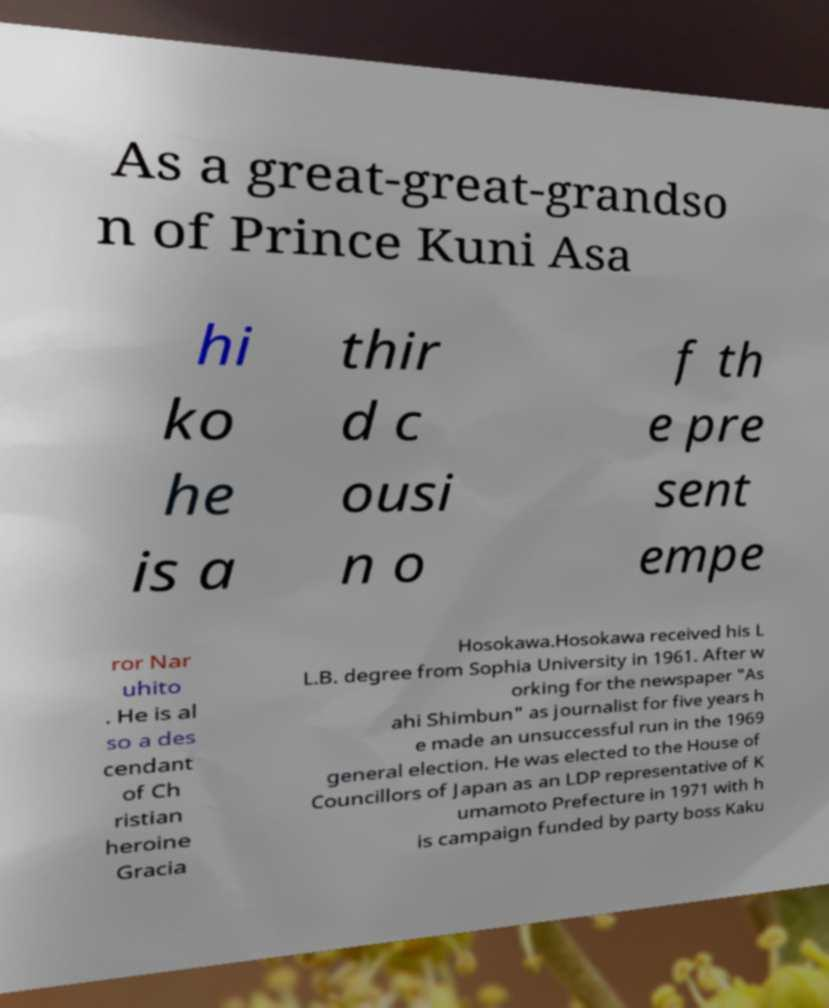Can you read and provide the text displayed in the image?This photo seems to have some interesting text. Can you extract and type it out for me? As a great-great-grandso n of Prince Kuni Asa hi ko he is a thir d c ousi n o f th e pre sent empe ror Nar uhito . He is al so a des cendant of Ch ristian heroine Gracia Hosokawa.Hosokawa received his L L.B. degree from Sophia University in 1961. After w orking for the newspaper "As ahi Shimbun" as journalist for five years h e made an unsuccessful run in the 1969 general election. He was elected to the House of Councillors of Japan as an LDP representative of K umamoto Prefecture in 1971 with h is campaign funded by party boss Kaku 